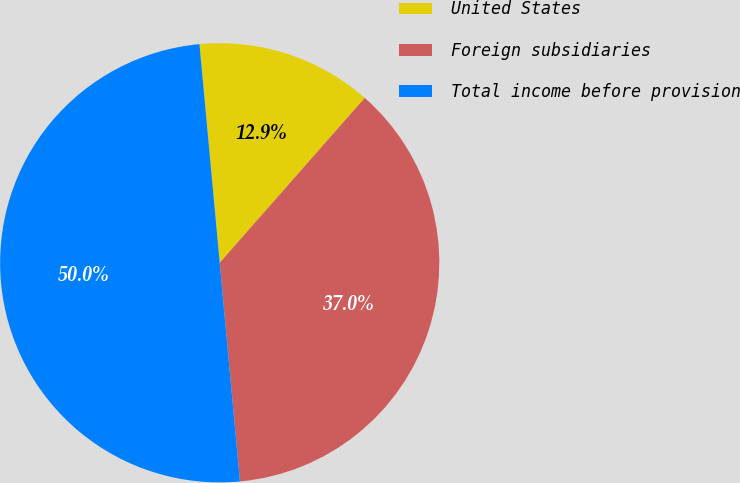Convert chart to OTSL. <chart><loc_0><loc_0><loc_500><loc_500><pie_chart><fcel>United States<fcel>Foreign subsidiaries<fcel>Total income before provision<nl><fcel>12.95%<fcel>37.05%<fcel>50.0%<nl></chart> 